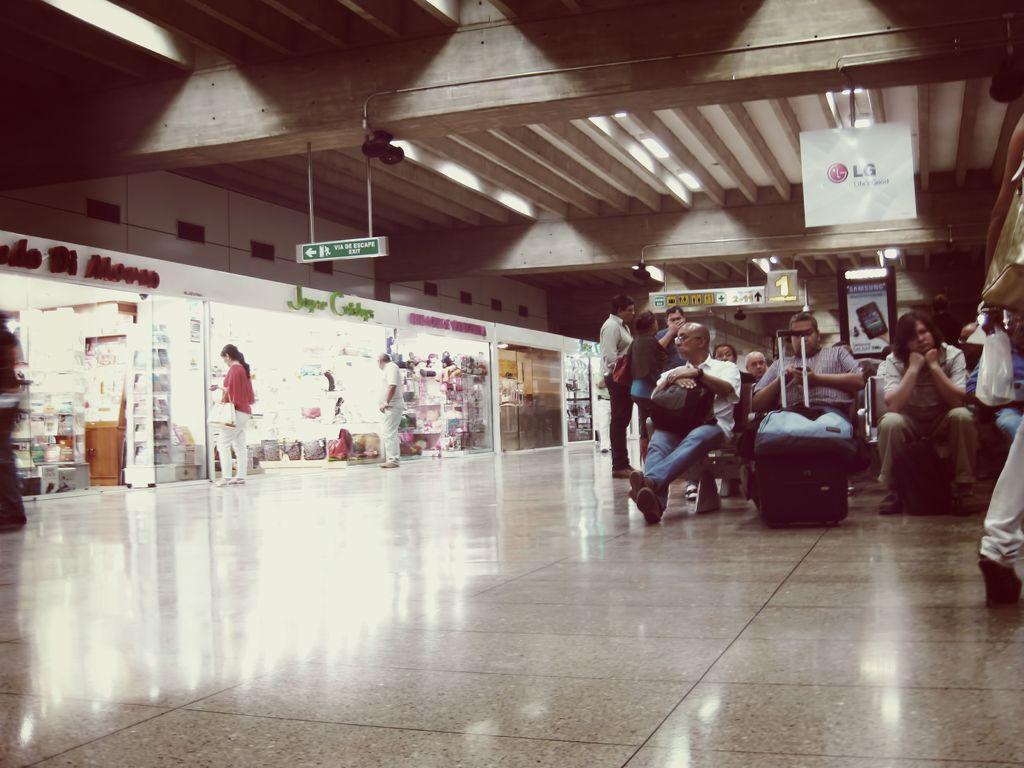Can you describe this image briefly? In this picture, there are stores towards the left. Before the stores, there is a woman and a man. Towards the right, there are people sitting on the chairs with the bags. One of the man is holding a bag on his lap. Beside him, there is another man holding a mobile. On the top, there are concrete pillars and a board. 